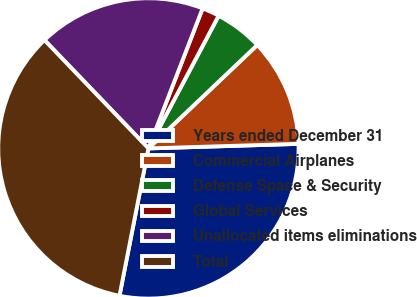Convert chart to OTSL. <chart><loc_0><loc_0><loc_500><loc_500><pie_chart><fcel>Years ended December 31<fcel>Commercial Airplanes<fcel>Defense Space & Security<fcel>Global Services<fcel>Unallocated items eliminations<fcel>Total<nl><fcel>28.57%<fcel>11.61%<fcel>5.16%<fcel>1.87%<fcel>18.05%<fcel>34.74%<nl></chart> 